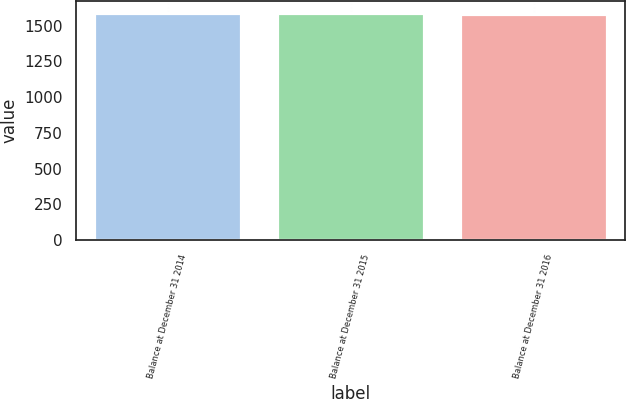Convert chart to OTSL. <chart><loc_0><loc_0><loc_500><loc_500><bar_chart><fcel>Balance at December 31 2014<fcel>Balance at December 31 2015<fcel>Balance at December 31 2016<nl><fcel>1590<fcel>1588<fcel>1585<nl></chart> 